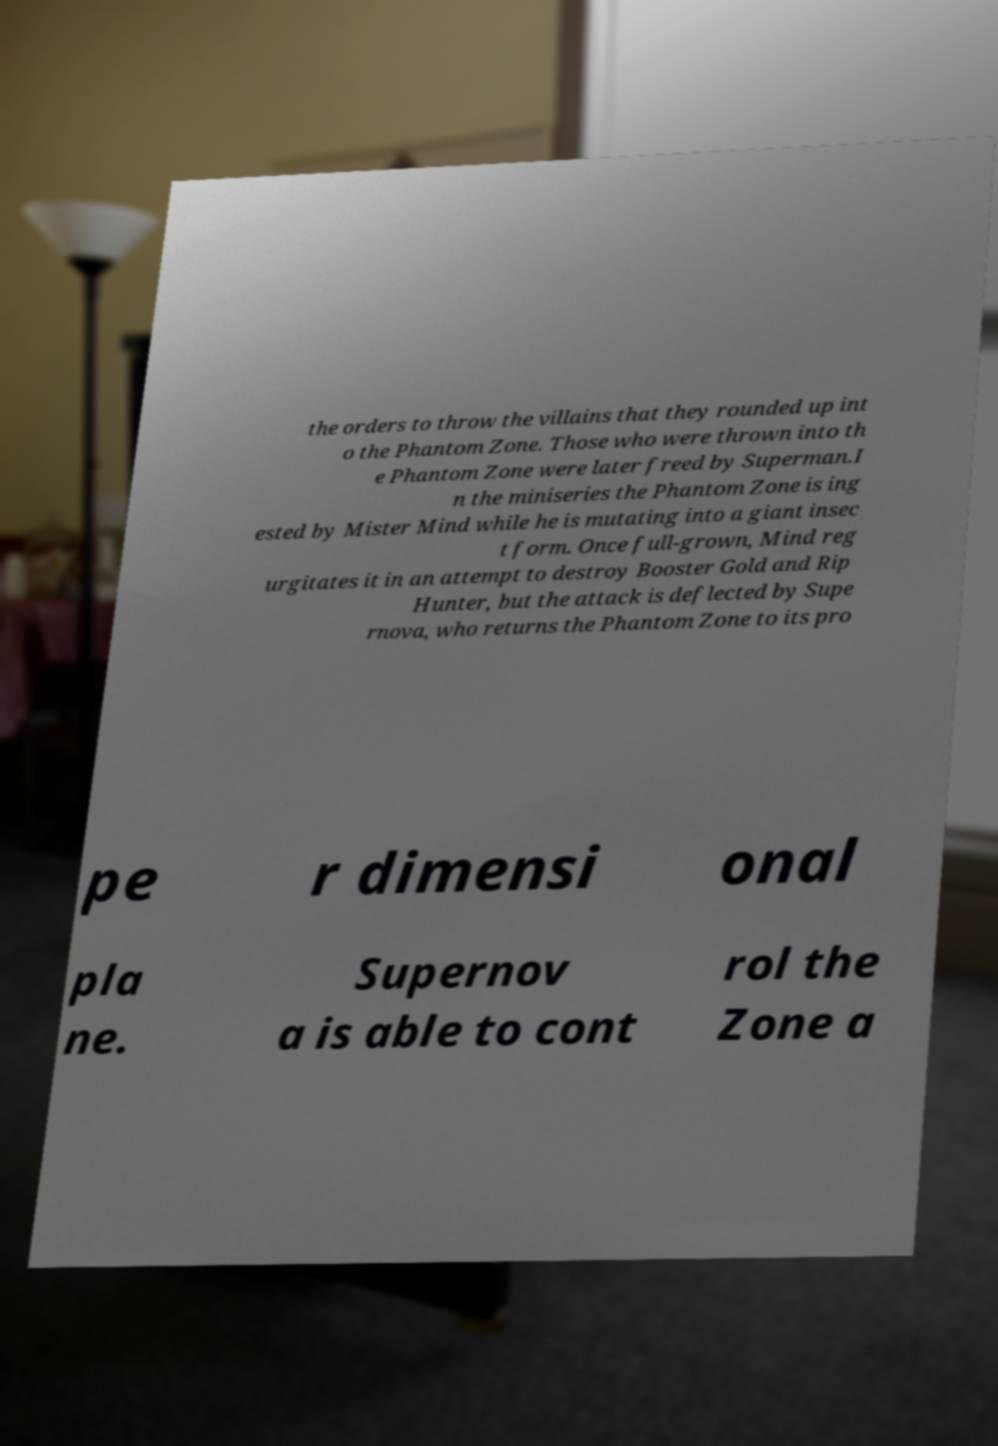There's text embedded in this image that I need extracted. Can you transcribe it verbatim? the orders to throw the villains that they rounded up int o the Phantom Zone. Those who were thrown into th e Phantom Zone were later freed by Superman.I n the miniseries the Phantom Zone is ing ested by Mister Mind while he is mutating into a giant insec t form. Once full-grown, Mind reg urgitates it in an attempt to destroy Booster Gold and Rip Hunter, but the attack is deflected by Supe rnova, who returns the Phantom Zone to its pro pe r dimensi onal pla ne. Supernov a is able to cont rol the Zone a 